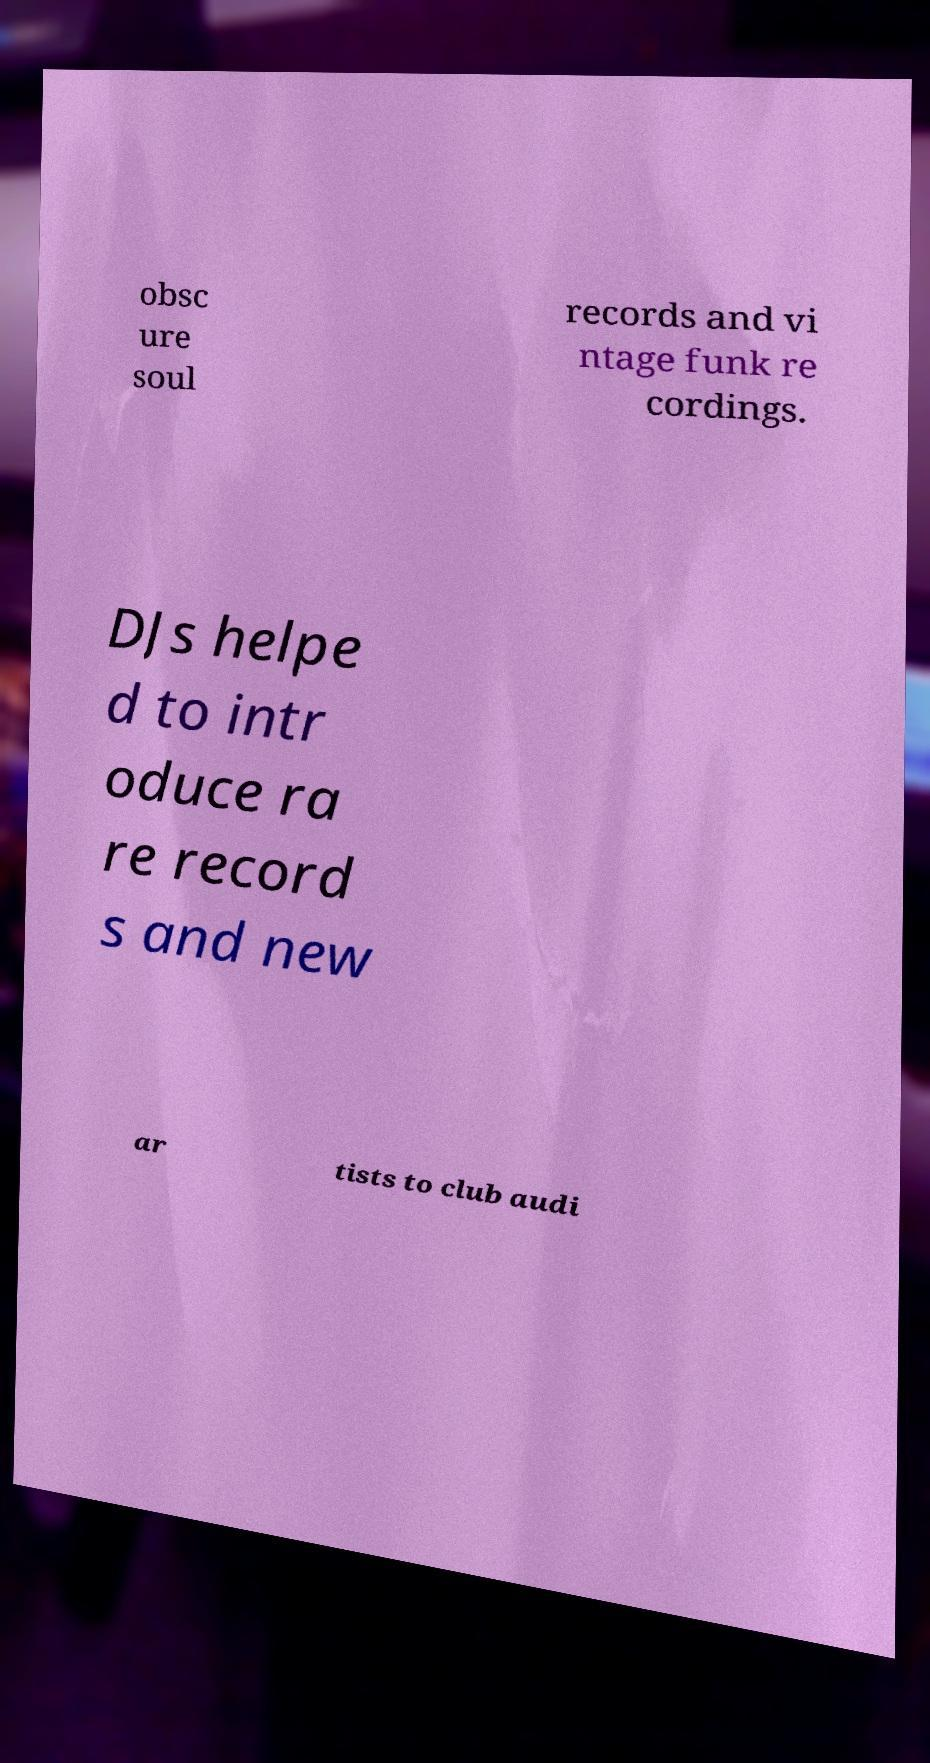I need the written content from this picture converted into text. Can you do that? obsc ure soul records and vi ntage funk re cordings. DJs helpe d to intr oduce ra re record s and new ar tists to club audi 